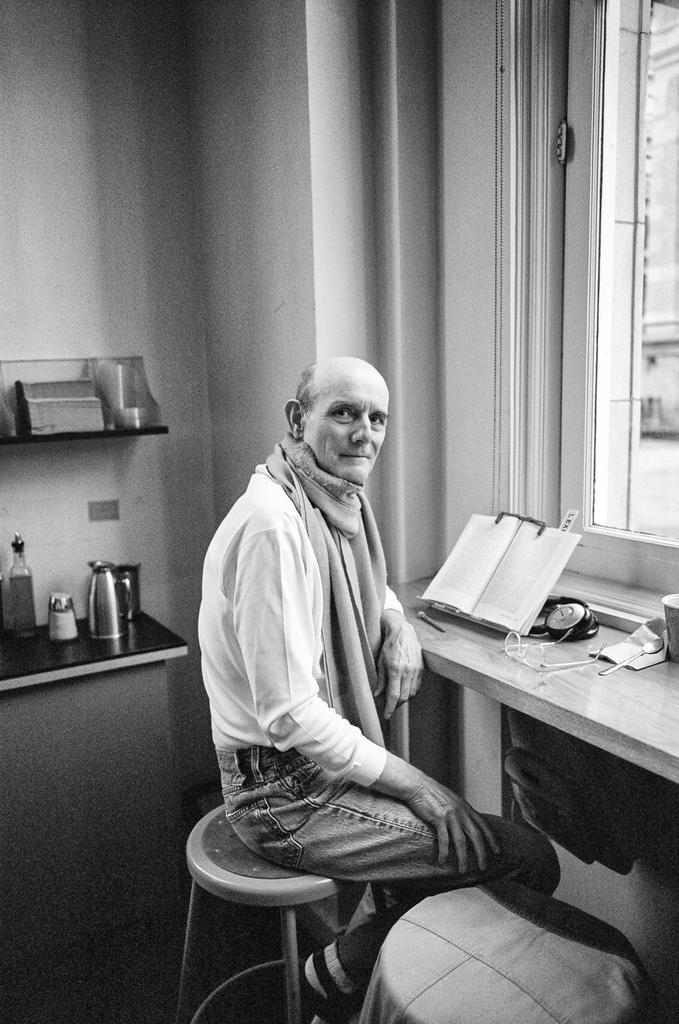In one or two sentences, can you explain what this image depicts? This image consists of a man sitting on a stool. He is wearing a white shirt and a blue jeans. In front of him, there is a book kept on the desk. On the right, there is a window. On the left, there is a desk on which a mug and a bottle are kept. In the background, there is a wall. 